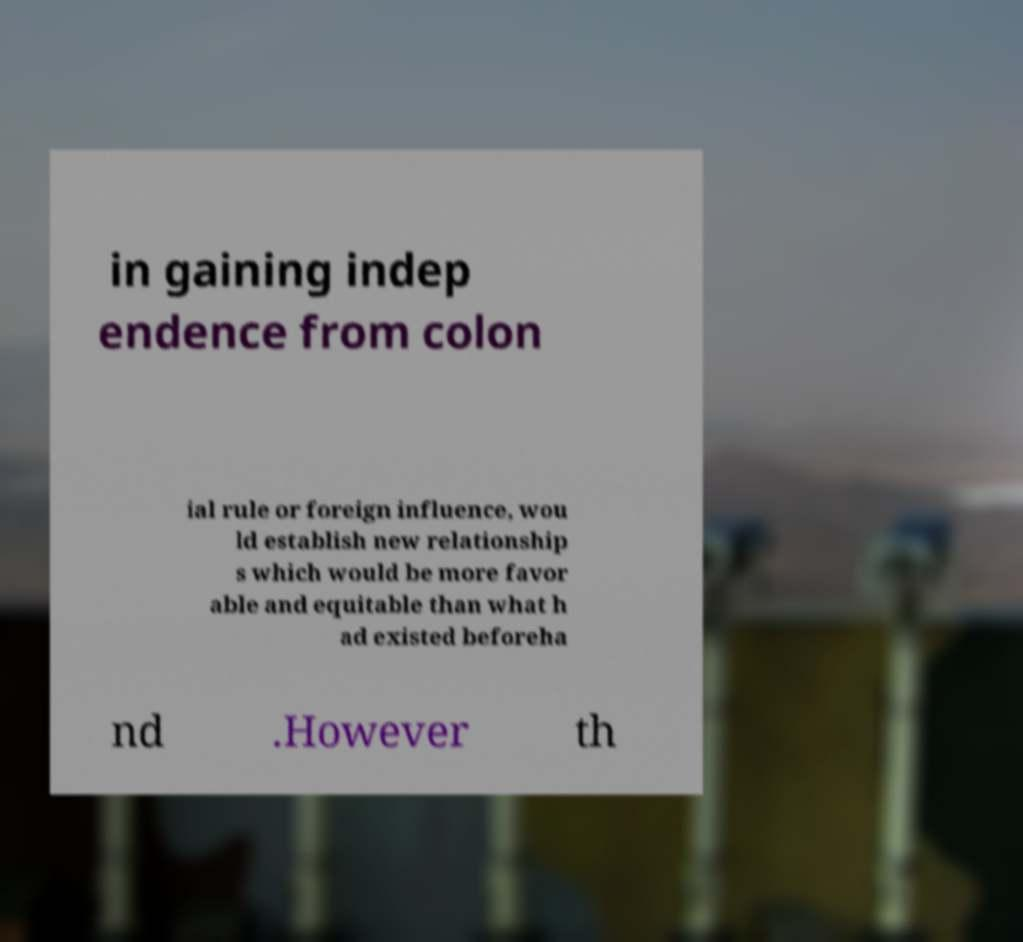Please identify and transcribe the text found in this image. in gaining indep endence from colon ial rule or foreign influence, wou ld establish new relationship s which would be more favor able and equitable than what h ad existed beforeha nd .However th 